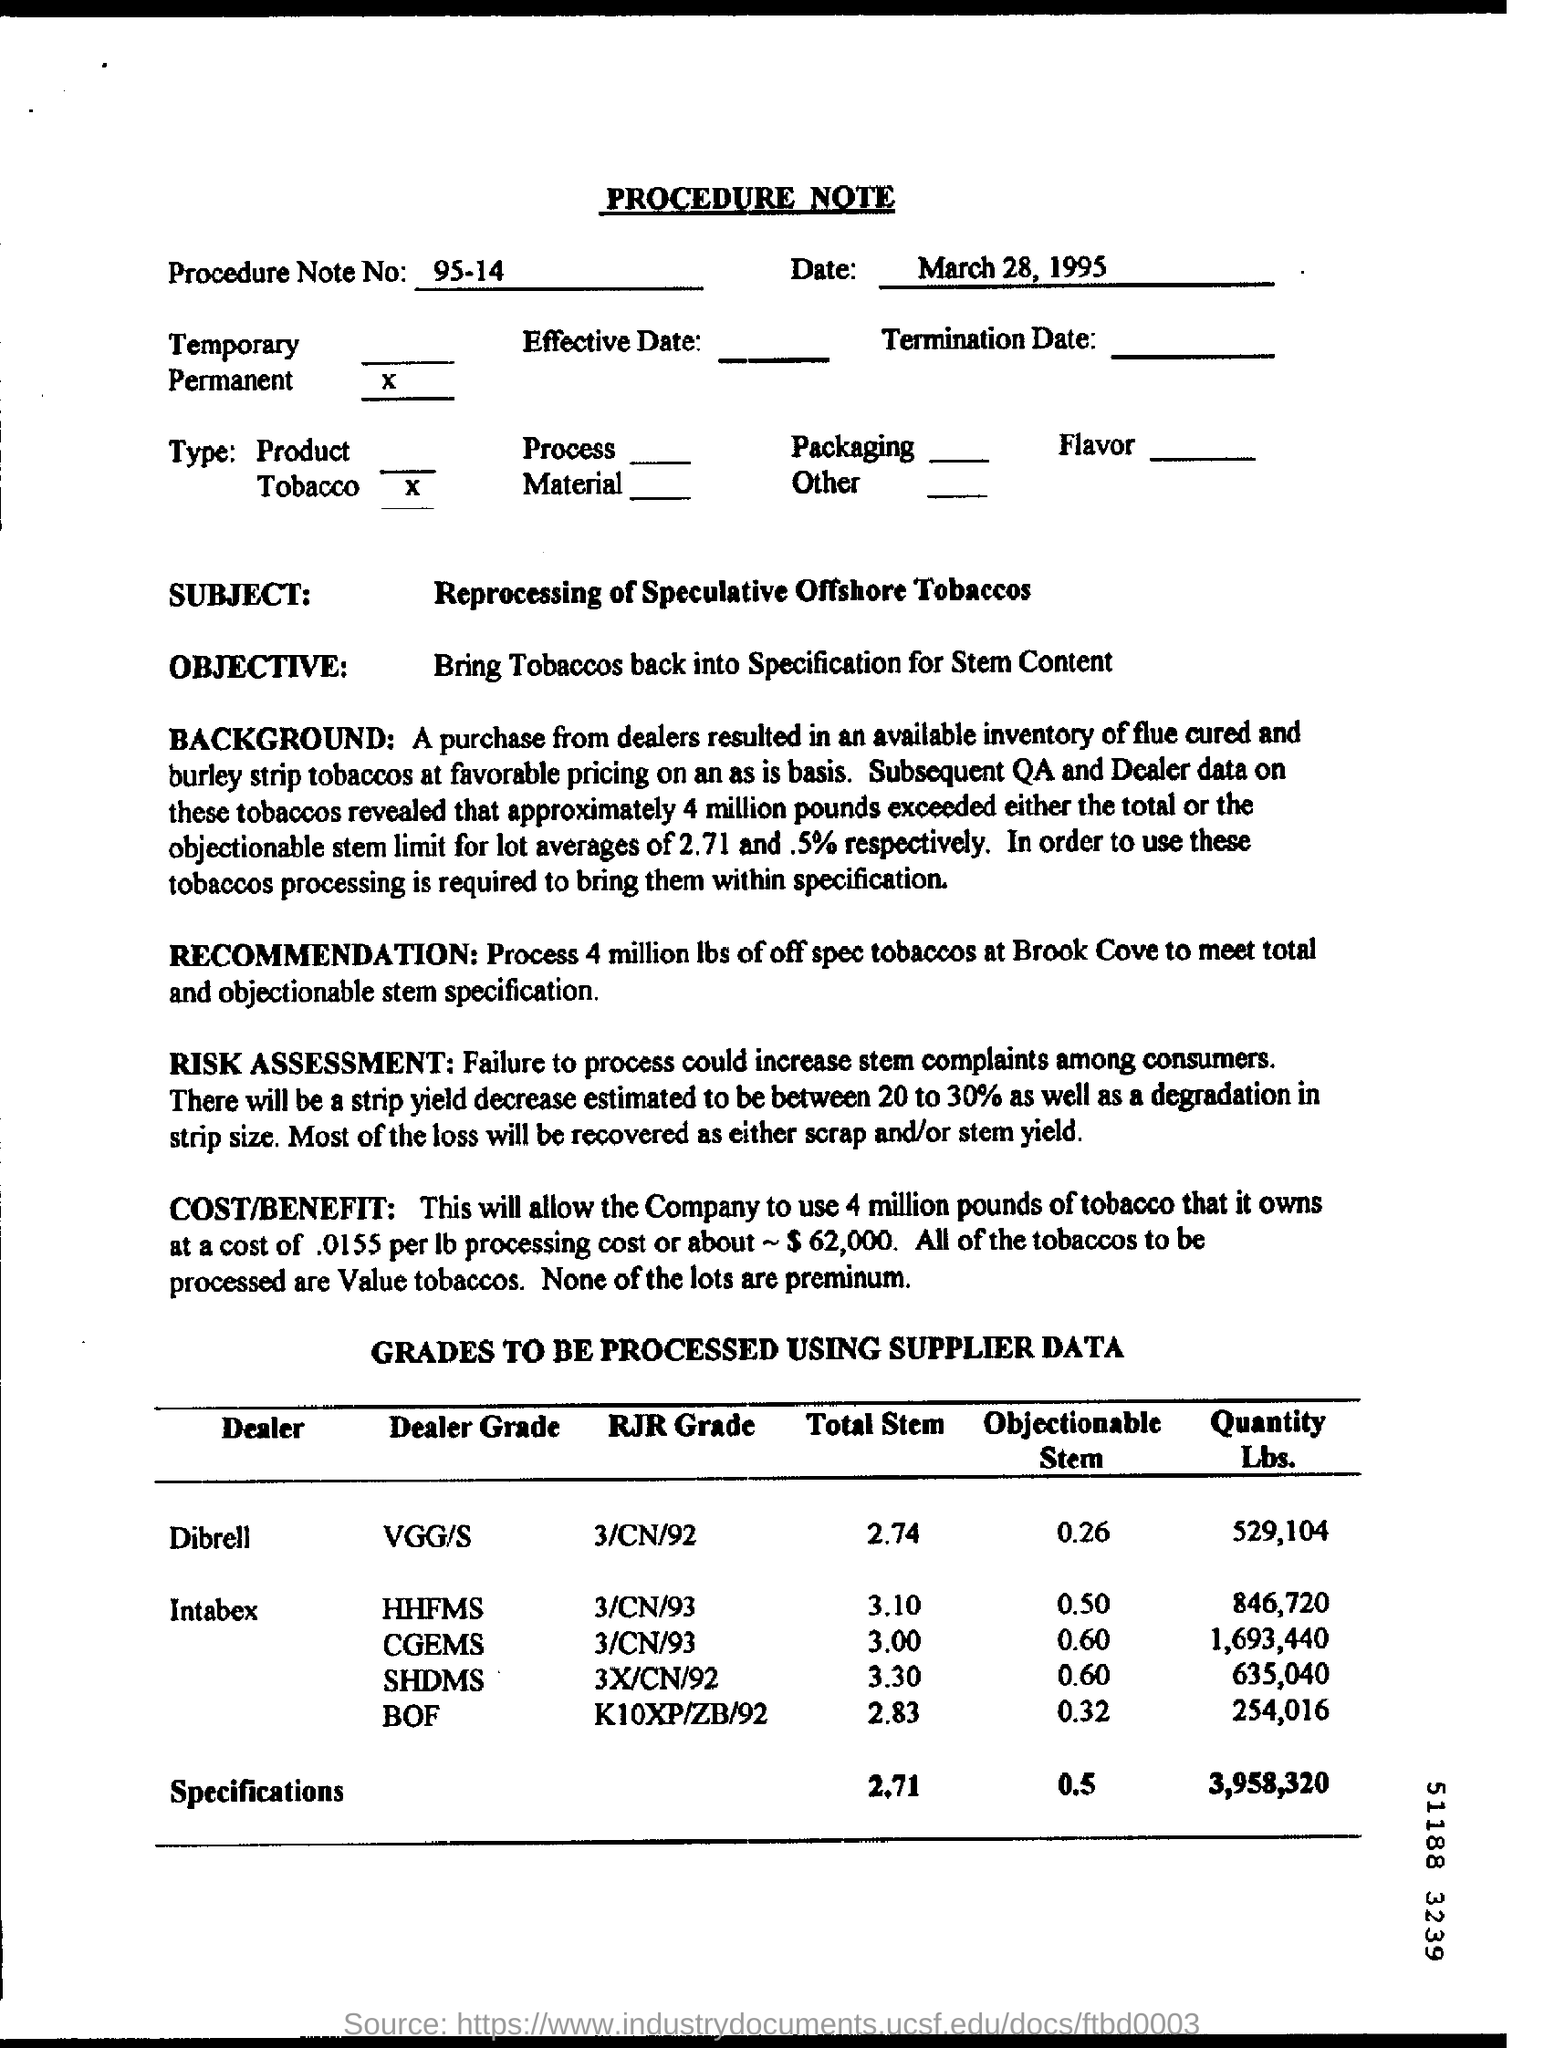What is the Procedure Note No. ?
Offer a terse response. 95-14. What is the Date on the Procedure Note?
Your response must be concise. March 28, 1995. What is the subject of the Note?
Your response must be concise. Reprocessing of speculative offshore tobaccos. What is the Obejectionable Stem for Dealer "Dibrell"?
Give a very brief answer. 0.26. What is the Total Stem for Dealer "Dibrell"?
Your response must be concise. 2.74. What is the Dealer Grade for Dealer "Dibrell"?
Offer a terse response. VGG/S. 